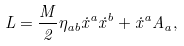<formula> <loc_0><loc_0><loc_500><loc_500>L = \frac { M } { 2 } \eta _ { a b } \dot { x } ^ { a } \dot { x } ^ { b } + \dot { x } ^ { a } A _ { a } ,</formula> 